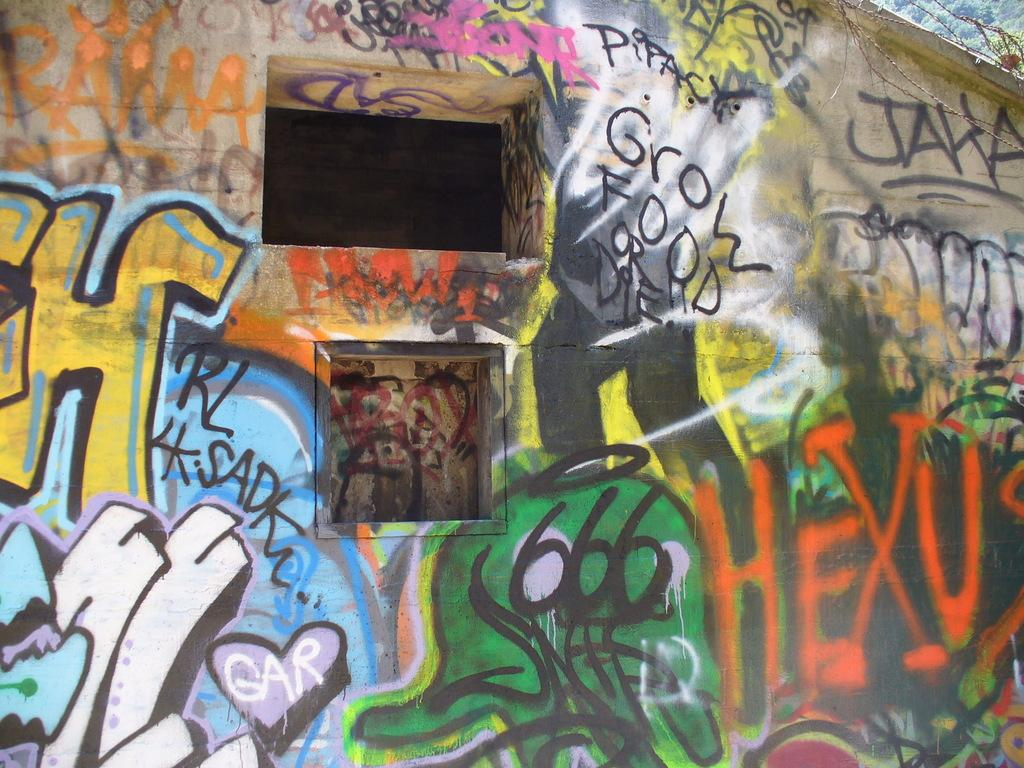What is on the wall in the image? There is graffiti on the wall in the image. What is located behind the wall in the image? There is a fence and trees visible behind the wall in the image. How many mice can be seen playing baseball in the image? There are no mice or baseball activity present in the image. 